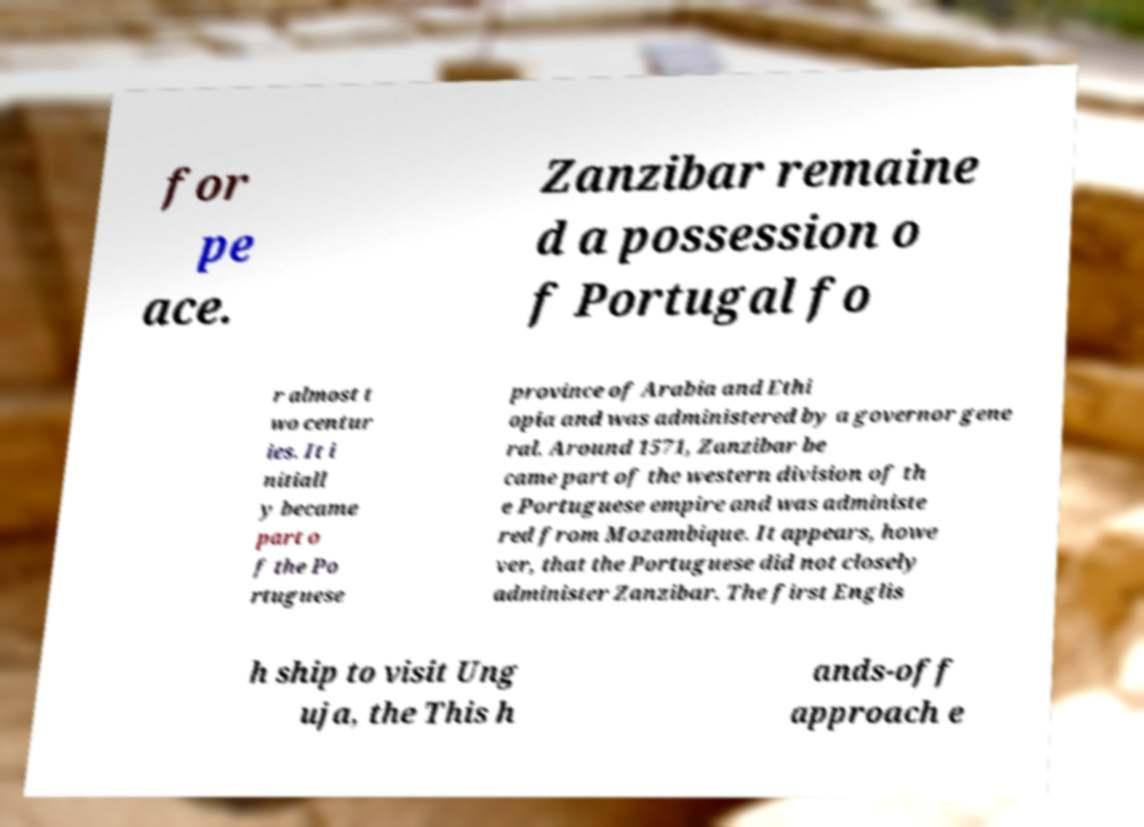There's text embedded in this image that I need extracted. Can you transcribe it verbatim? for pe ace. Zanzibar remaine d a possession o f Portugal fo r almost t wo centur ies. It i nitiall y became part o f the Po rtuguese province of Arabia and Ethi opia and was administered by a governor gene ral. Around 1571, Zanzibar be came part of the western division of th e Portuguese empire and was administe red from Mozambique. It appears, howe ver, that the Portuguese did not closely administer Zanzibar. The first Englis h ship to visit Ung uja, the This h ands-off approach e 